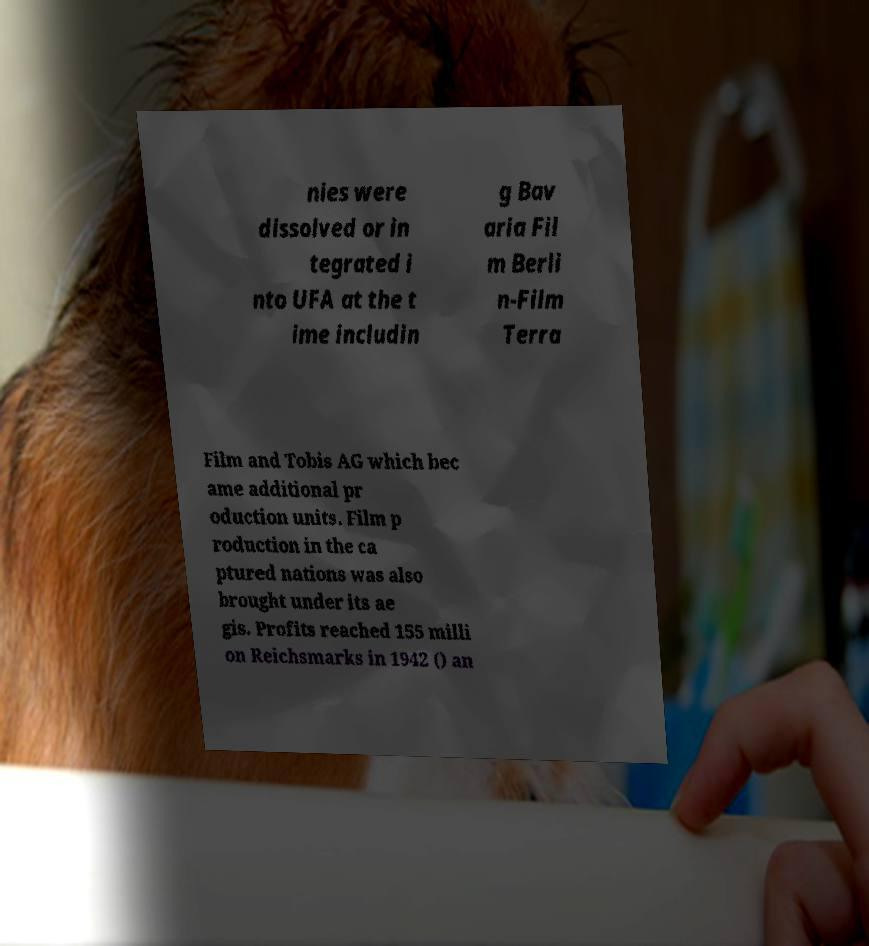Could you assist in decoding the text presented in this image and type it out clearly? nies were dissolved or in tegrated i nto UFA at the t ime includin g Bav aria Fil m Berli n-Film Terra Film and Tobis AG which bec ame additional pr oduction units. Film p roduction in the ca ptured nations was also brought under its ae gis. Profits reached 155 milli on Reichsmarks in 1942 () an 